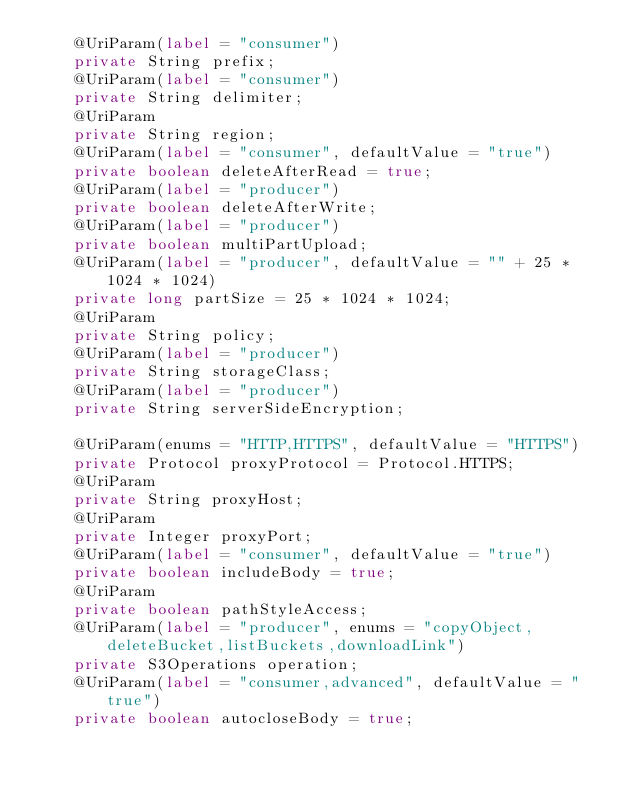<code> <loc_0><loc_0><loc_500><loc_500><_Java_>    @UriParam(label = "consumer")
    private String prefix;
    @UriParam(label = "consumer")
    private String delimiter;
    @UriParam
    private String region;
    @UriParam(label = "consumer", defaultValue = "true")
    private boolean deleteAfterRead = true;
    @UriParam(label = "producer")
    private boolean deleteAfterWrite;
    @UriParam(label = "producer")
    private boolean multiPartUpload;
    @UriParam(label = "producer", defaultValue = "" + 25 * 1024 * 1024)
    private long partSize = 25 * 1024 * 1024;
    @UriParam
    private String policy;
    @UriParam(label = "producer")
    private String storageClass;
    @UriParam(label = "producer")
    private String serverSideEncryption;

    @UriParam(enums = "HTTP,HTTPS", defaultValue = "HTTPS")
    private Protocol proxyProtocol = Protocol.HTTPS;
    @UriParam
    private String proxyHost;
    @UriParam
    private Integer proxyPort;
    @UriParam(label = "consumer", defaultValue = "true")
    private boolean includeBody = true;
    @UriParam
    private boolean pathStyleAccess;
    @UriParam(label = "producer", enums = "copyObject,deleteBucket,listBuckets,downloadLink")
    private S3Operations operation;
    @UriParam(label = "consumer,advanced", defaultValue = "true")
    private boolean autocloseBody = true;</code> 